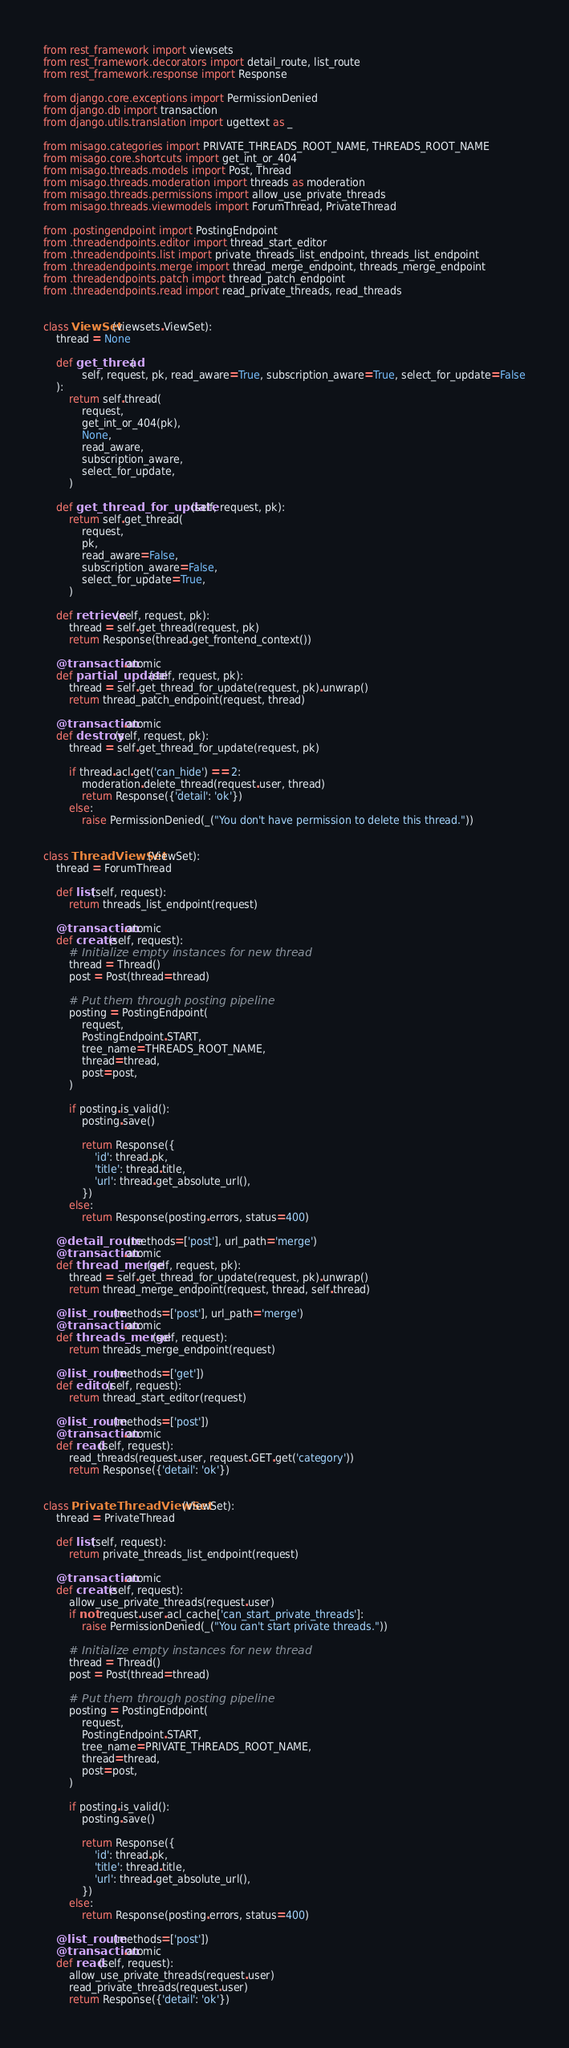<code> <loc_0><loc_0><loc_500><loc_500><_Python_>from rest_framework import viewsets
from rest_framework.decorators import detail_route, list_route
from rest_framework.response import Response

from django.core.exceptions import PermissionDenied
from django.db import transaction
from django.utils.translation import ugettext as _

from misago.categories import PRIVATE_THREADS_ROOT_NAME, THREADS_ROOT_NAME
from misago.core.shortcuts import get_int_or_404
from misago.threads.models import Post, Thread
from misago.threads.moderation import threads as moderation
from misago.threads.permissions import allow_use_private_threads
from misago.threads.viewmodels import ForumThread, PrivateThread

from .postingendpoint import PostingEndpoint
from .threadendpoints.editor import thread_start_editor
from .threadendpoints.list import private_threads_list_endpoint, threads_list_endpoint
from .threadendpoints.merge import thread_merge_endpoint, threads_merge_endpoint
from .threadendpoints.patch import thread_patch_endpoint
from .threadendpoints.read import read_private_threads, read_threads


class ViewSet(viewsets.ViewSet):
    thread = None

    def get_thread(
            self, request, pk, read_aware=True, subscription_aware=True, select_for_update=False
    ):
        return self.thread(
            request,
            get_int_or_404(pk),
            None,
            read_aware,
            subscription_aware,
            select_for_update,
        )

    def get_thread_for_update(self, request, pk):
        return self.get_thread(
            request,
            pk,
            read_aware=False,
            subscription_aware=False,
            select_for_update=True,
        )

    def retrieve(self, request, pk):
        thread = self.get_thread(request, pk)
        return Response(thread.get_frontend_context())

    @transaction.atomic
    def partial_update(self, request, pk):
        thread = self.get_thread_for_update(request, pk).unwrap()
        return thread_patch_endpoint(request, thread)

    @transaction.atomic
    def destroy(self, request, pk):
        thread = self.get_thread_for_update(request, pk)

        if thread.acl.get('can_hide') == 2:
            moderation.delete_thread(request.user, thread)
            return Response({'detail': 'ok'})
        else:
            raise PermissionDenied(_("You don't have permission to delete this thread."))


class ThreadViewSet(ViewSet):
    thread = ForumThread

    def list(self, request):
        return threads_list_endpoint(request)

    @transaction.atomic
    def create(self, request):
        # Initialize empty instances for new thread
        thread = Thread()
        post = Post(thread=thread)

        # Put them through posting pipeline
        posting = PostingEndpoint(
            request,
            PostingEndpoint.START,
            tree_name=THREADS_ROOT_NAME,
            thread=thread,
            post=post,
        )

        if posting.is_valid():
            posting.save()

            return Response({
                'id': thread.pk,
                'title': thread.title,
                'url': thread.get_absolute_url(),
            })
        else:
            return Response(posting.errors, status=400)

    @detail_route(methods=['post'], url_path='merge')
    @transaction.atomic
    def thread_merge(self, request, pk):
        thread = self.get_thread_for_update(request, pk).unwrap()
        return thread_merge_endpoint(request, thread, self.thread)

    @list_route(methods=['post'], url_path='merge')
    @transaction.atomic
    def threads_merge(self, request):
        return threads_merge_endpoint(request)

    @list_route(methods=['get'])
    def editor(self, request):
        return thread_start_editor(request)

    @list_route(methods=['post'])
    @transaction.atomic
    def read(self, request):
        read_threads(request.user, request.GET.get('category'))
        return Response({'detail': 'ok'})


class PrivateThreadViewSet(ViewSet):
    thread = PrivateThread

    def list(self, request):
        return private_threads_list_endpoint(request)

    @transaction.atomic
    def create(self, request):
        allow_use_private_threads(request.user)
        if not request.user.acl_cache['can_start_private_threads']:
            raise PermissionDenied(_("You can't start private threads."))

        # Initialize empty instances for new thread
        thread = Thread()
        post = Post(thread=thread)

        # Put them through posting pipeline
        posting = PostingEndpoint(
            request,
            PostingEndpoint.START,
            tree_name=PRIVATE_THREADS_ROOT_NAME,
            thread=thread,
            post=post,
        )

        if posting.is_valid():
            posting.save()

            return Response({
                'id': thread.pk,
                'title': thread.title,
                'url': thread.get_absolute_url(),
            })
        else:
            return Response(posting.errors, status=400)

    @list_route(methods=['post'])
    @transaction.atomic
    def read(self, request):
        allow_use_private_threads(request.user)
        read_private_threads(request.user)
        return Response({'detail': 'ok'})
</code> 